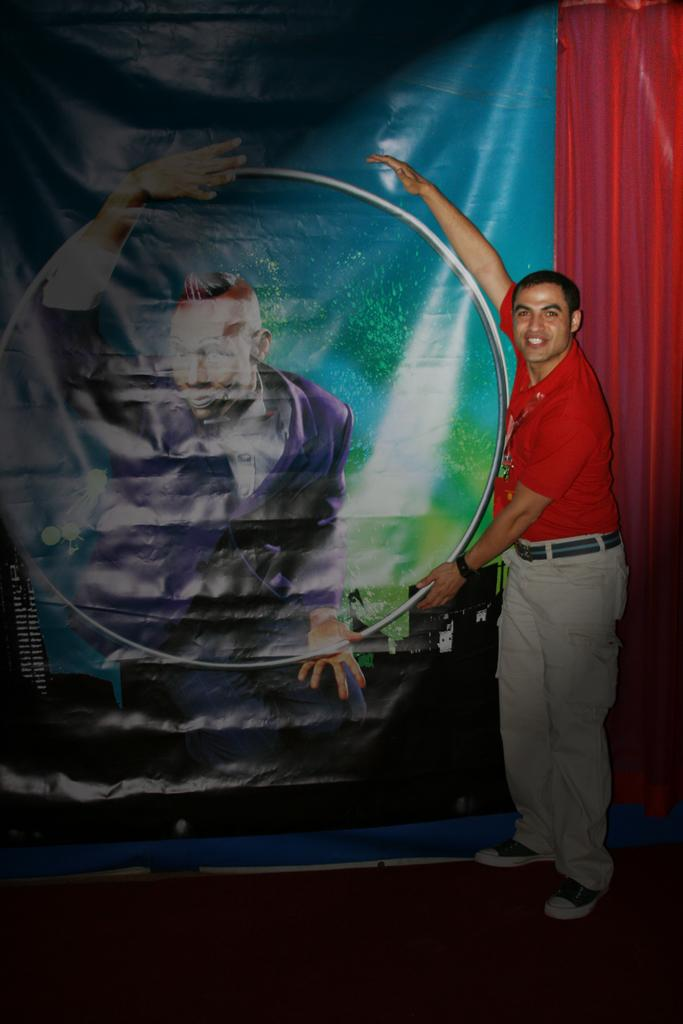What is the main subject of the image? There is a person standing in the image. What can be observed about the person's attire? The person is wearing clothes. What else is present in the image besides the person? There is a banner in the middle of the image. How many babies are crawling on the person's tongue in the image? There are no babies or tongues visible in the image; it features a person standing and a banner. 